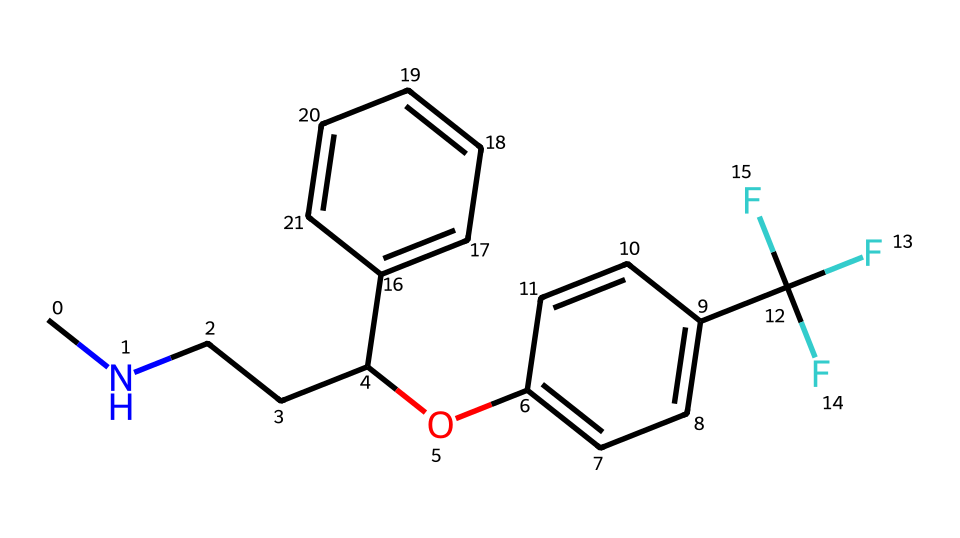What is the molecular formula of fluoxetine? The SMILES representation can be translated into the molecular formula by identifying the elements and their respective quantities. From the structure, we count: 17 carbon (C) atoms, 18 hydrogen (H) atoms, 2 nitrogen (N) atoms, 1 oxygen (O) atom, and 3 fluorine (F) atoms, leading to the formula C17H18F3N2O.
Answer: C17H18F3N2O How many aromatic rings are present in this structure? By analyzing the structure in the SMILES representation, we can identify the carbon rings. There are two benzene-like structures that are part of the overall chemical framework, indicating two aromatic rings.
Answer: 2 What functional group is indicated by the "Oc" portion of the structure? The "Oc" part of the SMILES denotes a hydroxyl group (-OH) bound to a carbon atom, indicating the presence of an ether functional group along with the aromatic ring. This implies it has the properties of a phenolic compound.
Answer: ether Are there any halogen atoms present in fluoxetine? The presence of "F" in the SMILES indicates the presence of fluorine atoms, which are halogens. Since there are three occurrences of "F," it confirms that there are halogen atoms in this chemical structure.
Answer: yes Which atoms are connected by a single bond in this structure? In the SMILES, single bonds primarily connect carbon (C) atoms to hydrogen (H) and to other carbon atoms. Additionally, the nitrogen (N) atoms are singly bonded to adjacent carbons, while the oxygen (O) is bound to carbon through a single bond. This relationship defines the bonding nature throughout the compound.
Answer: carbon and hydrogen What type of drug classification does fluoxetine belong to? By recognizing the presence of certain functional groups and the overall structure, fluoxetine is classified within the group of selective serotonin reuptake inhibitors (SSRIs) used for antidepressant purposes. This classification is derived from its action mechanism in the brain.
Answer: antidepressant 